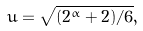<formula> <loc_0><loc_0><loc_500><loc_500>u = \sqrt { ( 2 ^ { \alpha } + 2 ) / 6 } ,</formula> 